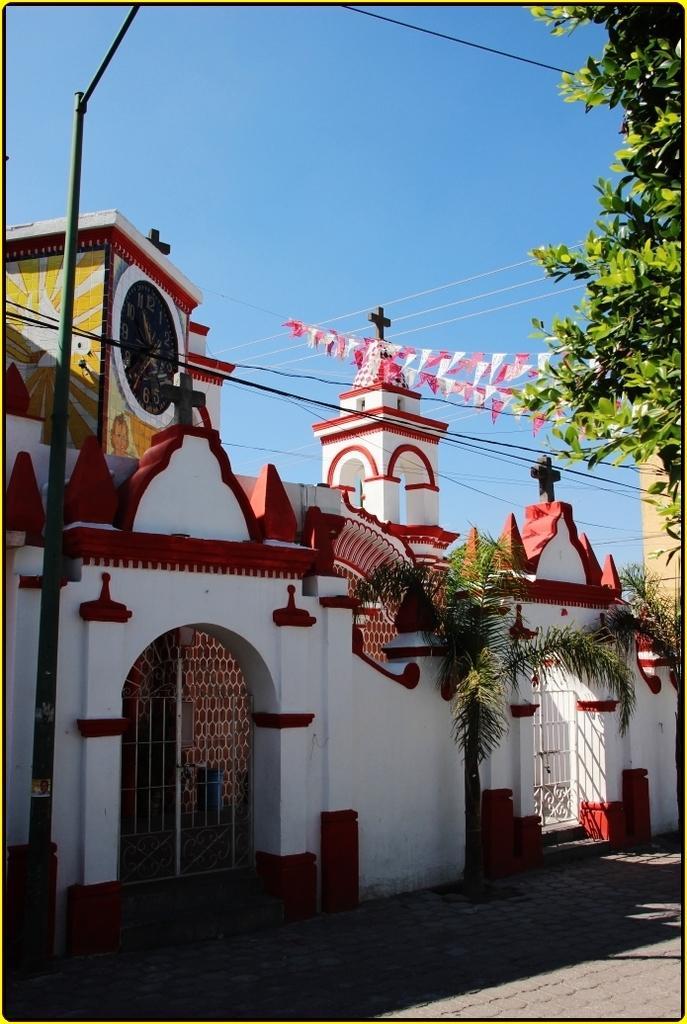How would you summarize this image in a sentence or two? In this image we can see white color wall, gate, clock to the tower, pole, wires, trees, decoration flags and the blue sky in the background. 